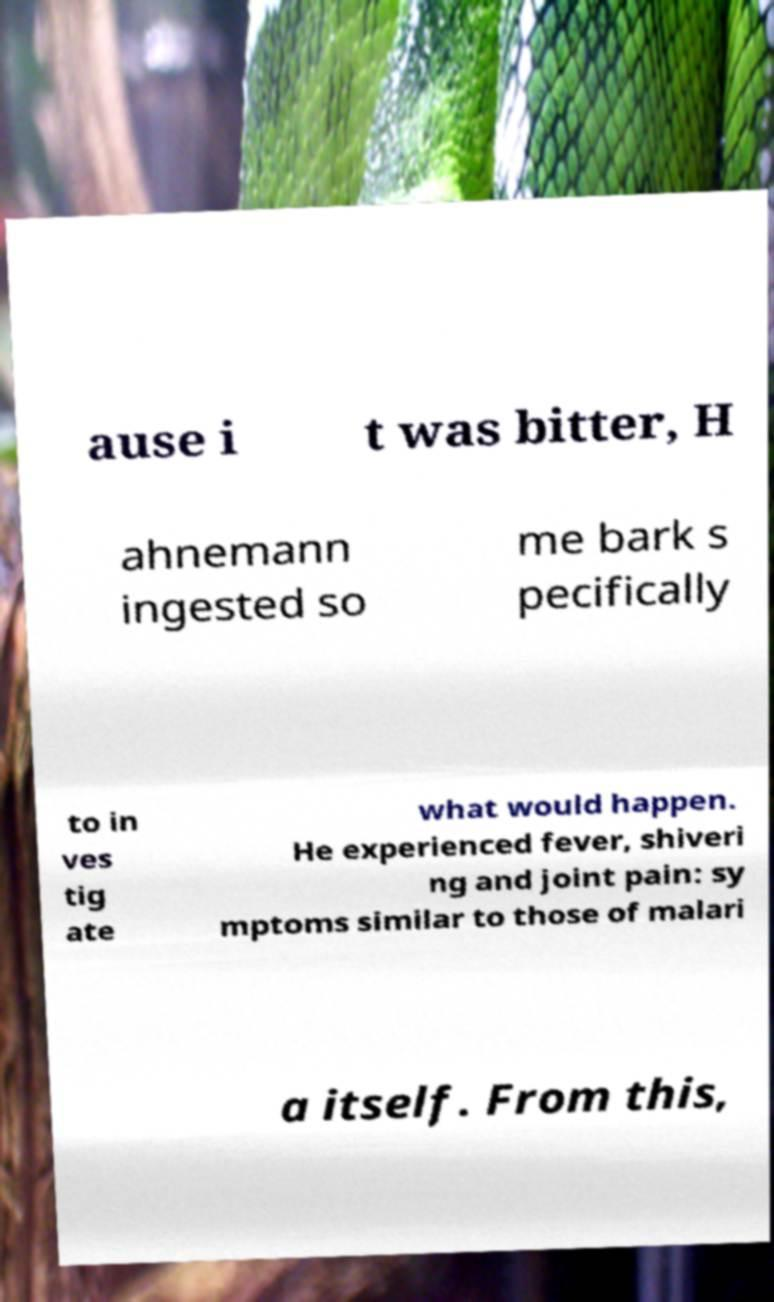Can you accurately transcribe the text from the provided image for me? ause i t was bitter, H ahnemann ingested so me bark s pecifically to in ves tig ate what would happen. He experienced fever, shiveri ng and joint pain: sy mptoms similar to those of malari a itself. From this, 